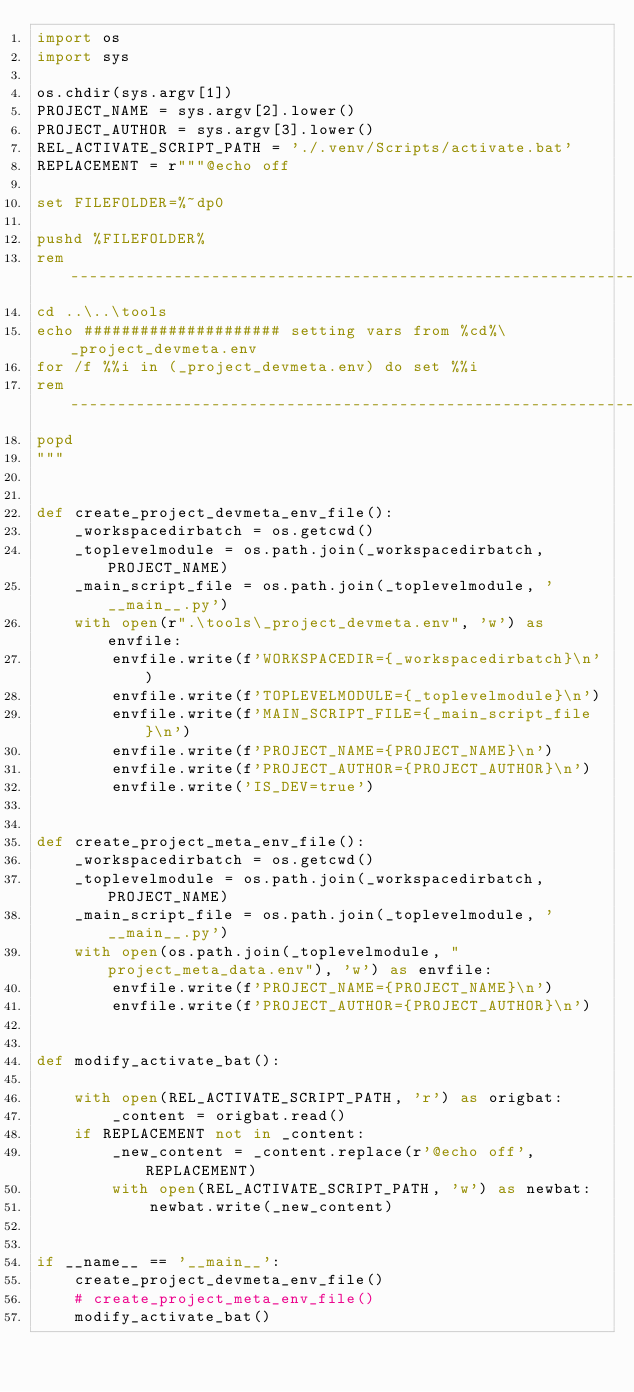Convert code to text. <code><loc_0><loc_0><loc_500><loc_500><_Python_>import os
import sys

os.chdir(sys.argv[1])
PROJECT_NAME = sys.argv[2].lower()
PROJECT_AUTHOR = sys.argv[3].lower()
REL_ACTIVATE_SCRIPT_PATH = './.venv/Scripts/activate.bat'
REPLACEMENT = r"""@echo off

set FILEFOLDER=%~dp0

pushd %FILEFOLDER%
rem ----------------------------------------------------------------
cd ..\..\tools
echo ##################### setting vars from %cd%\_project_devmeta.env
for /f %%i in (_project_devmeta.env) do set %%i
rem ----------------------------------------------------------------
popd
"""


def create_project_devmeta_env_file():
    _workspacedirbatch = os.getcwd()
    _toplevelmodule = os.path.join(_workspacedirbatch, PROJECT_NAME)
    _main_script_file = os.path.join(_toplevelmodule, '__main__.py')
    with open(r".\tools\_project_devmeta.env", 'w') as envfile:
        envfile.write(f'WORKSPACEDIR={_workspacedirbatch}\n')
        envfile.write(f'TOPLEVELMODULE={_toplevelmodule}\n')
        envfile.write(f'MAIN_SCRIPT_FILE={_main_script_file}\n')
        envfile.write(f'PROJECT_NAME={PROJECT_NAME}\n')
        envfile.write(f'PROJECT_AUTHOR={PROJECT_AUTHOR}\n')
        envfile.write('IS_DEV=true')


def create_project_meta_env_file():
    _workspacedirbatch = os.getcwd()
    _toplevelmodule = os.path.join(_workspacedirbatch, PROJECT_NAME)
    _main_script_file = os.path.join(_toplevelmodule, '__main__.py')
    with open(os.path.join(_toplevelmodule, "project_meta_data.env"), 'w') as envfile:
        envfile.write(f'PROJECT_NAME={PROJECT_NAME}\n')
        envfile.write(f'PROJECT_AUTHOR={PROJECT_AUTHOR}\n')


def modify_activate_bat():

    with open(REL_ACTIVATE_SCRIPT_PATH, 'r') as origbat:
        _content = origbat.read()
    if REPLACEMENT not in _content:
        _new_content = _content.replace(r'@echo off', REPLACEMENT)
        with open(REL_ACTIVATE_SCRIPT_PATH, 'w') as newbat:
            newbat.write(_new_content)


if __name__ == '__main__':
    create_project_devmeta_env_file()
    # create_project_meta_env_file()
    modify_activate_bat()
</code> 